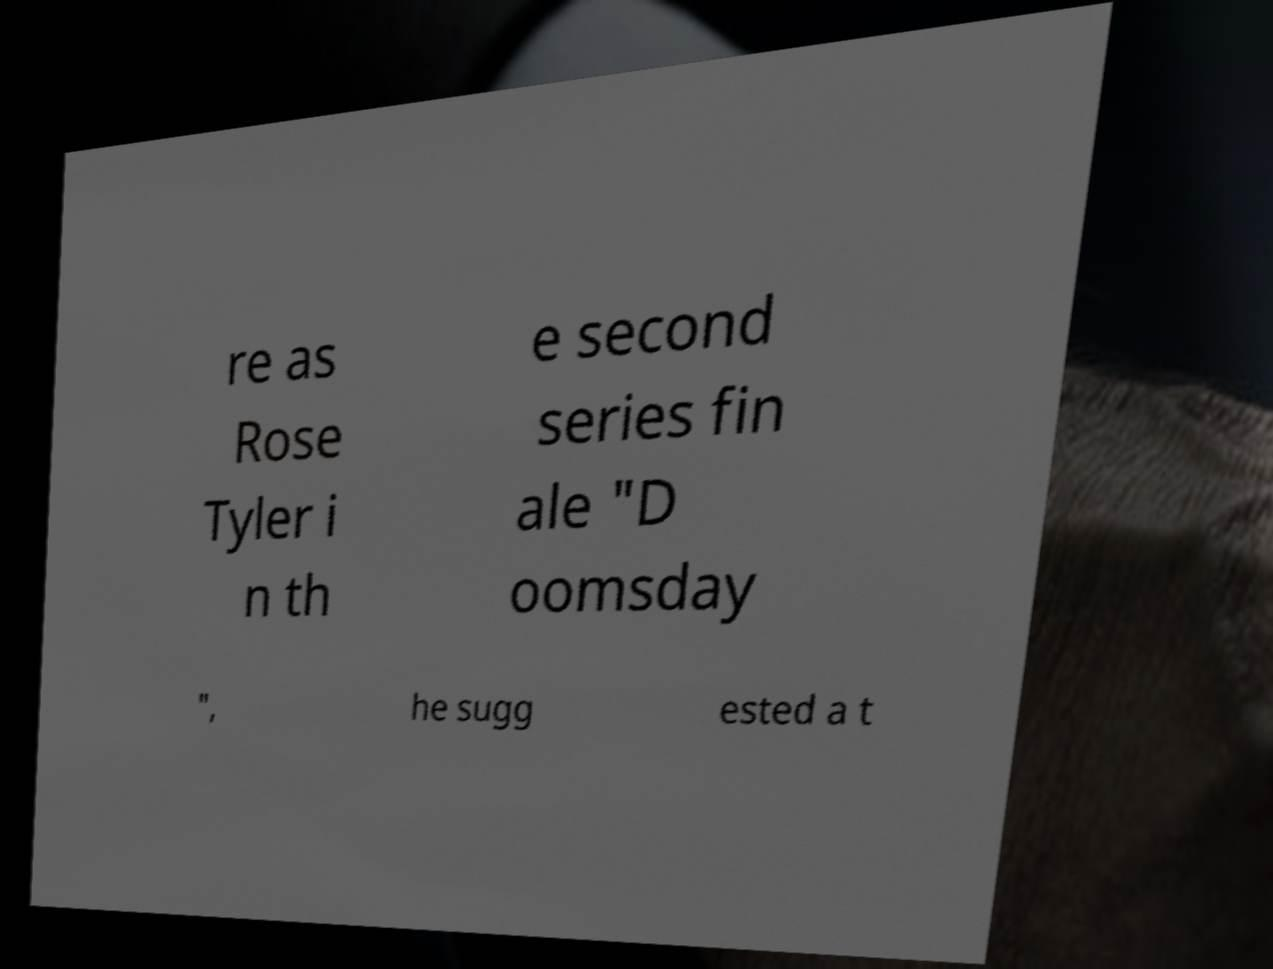Please read and relay the text visible in this image. What does it say? re as Rose Tyler i n th e second series fin ale "D oomsday ", he sugg ested a t 